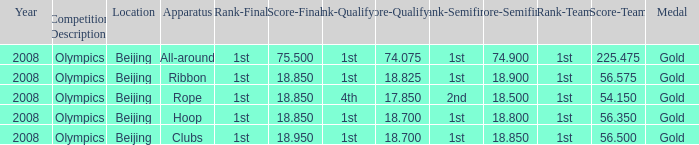What was her final score on the ribbon apparatus? 18.85. 